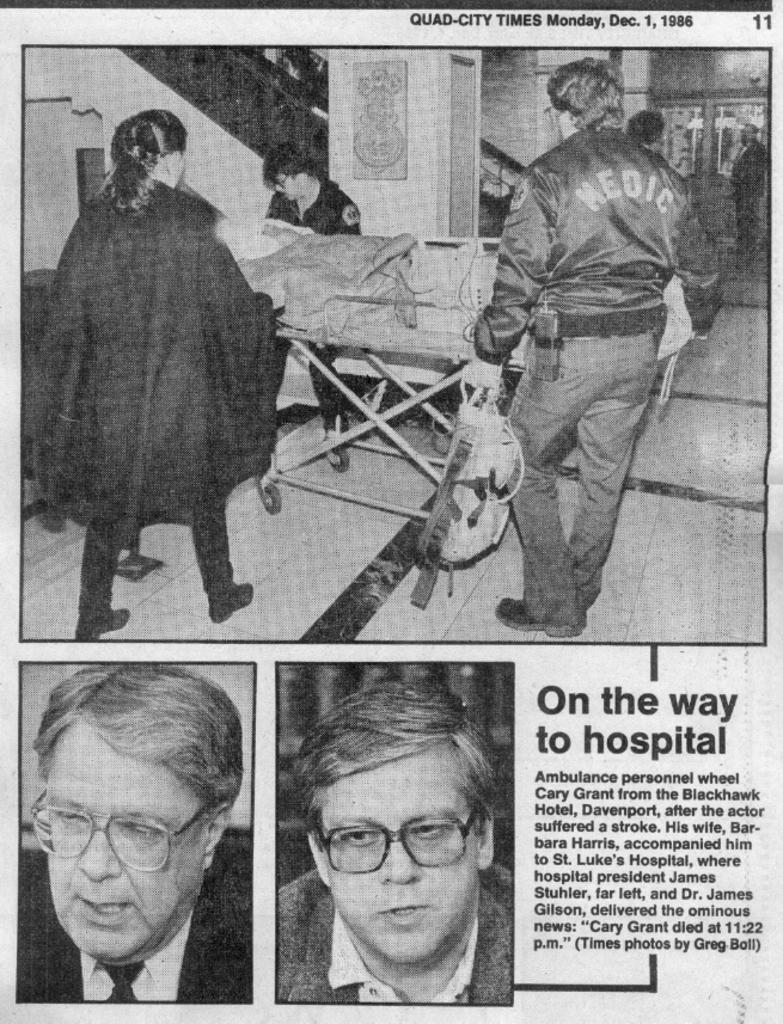<image>
Give a short and clear explanation of the subsequent image. A page from the Quad-City Times shows Medics escorting a stretcher. 